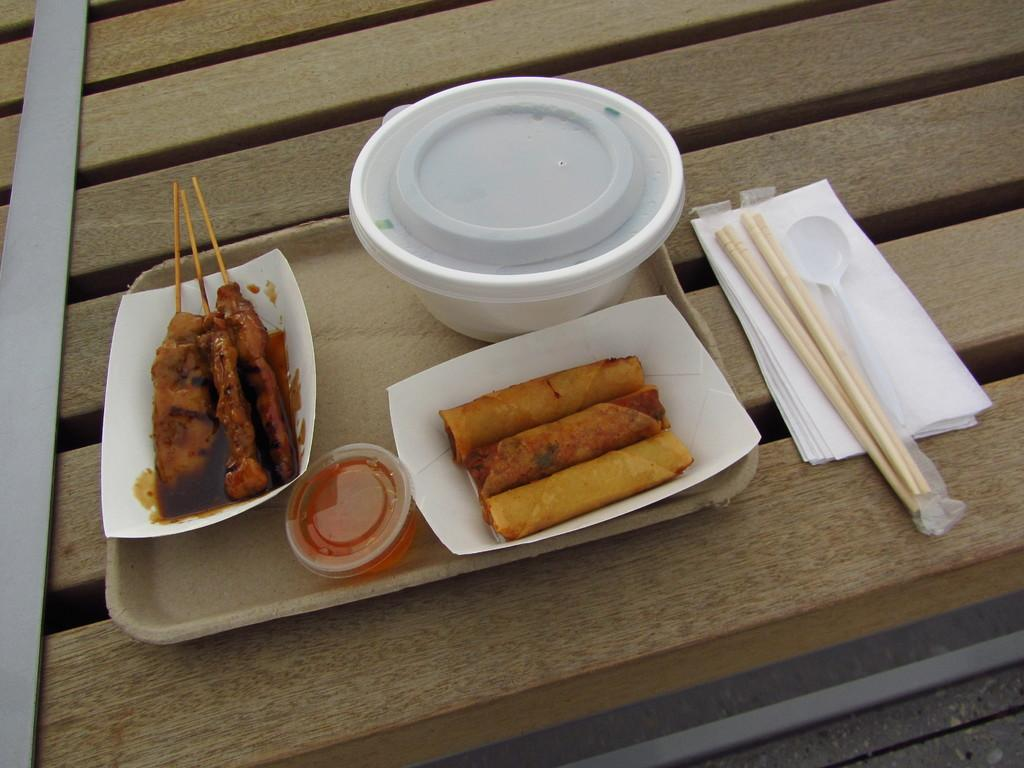What type of furniture is in the image? There is a table in the image. What is placed on the table? A tray, tissue papers, a spoon, a bowl, a plate, and food items are on the table. What can be used for eating or serving food in the image? The spoon and the plate can be used for eating or serving food in the image. What is the setting of the image? The image is taken inside a room. What type of star can be seen in the image? There is no star present in the image; it is taken inside a room. Is there a slope in the image? There is no slope present in the image; it is taken inside a room with a table and various items on it. 